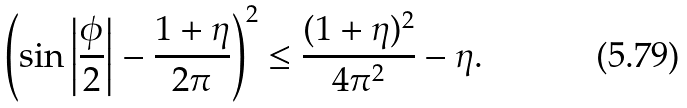<formula> <loc_0><loc_0><loc_500><loc_500>\left ( \sin { \left | \frac { \phi } { 2 } \right | } - \frac { 1 + \eta } { 2 \pi } \right ) ^ { 2 } \leq \frac { ( 1 + \eta ) ^ { 2 } } { 4 \pi ^ { 2 } } - \eta .</formula> 